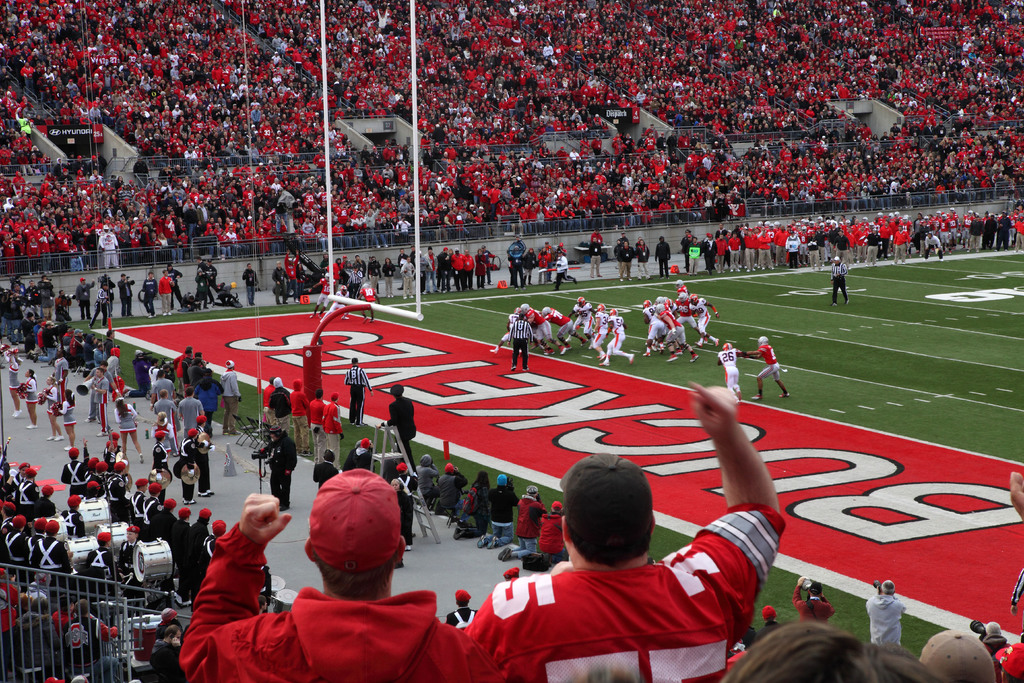Can you give me more details about what's happening on the field? On the field, we have a classic offensive setup, with a team lined up across from their opponents, preparing for the next play. The team in white, which is on offense, is likely strategizing to advance the ball to score points, while the team in red is defending their end zone. Referees can be seen standing by to officiate the play, ensuring the game proceeds with fairness and according to the rules. What could the outcome of this particular play mean for the game? The outcome of this play could be pivotal. If the offensive team (in white) breaks through the defense and scores, it could swing momentum in their favor or widen their lead. Conversely, a defensive stop by the red team could energize their fans and provide an opportunity to take control of the game during the next possession. 